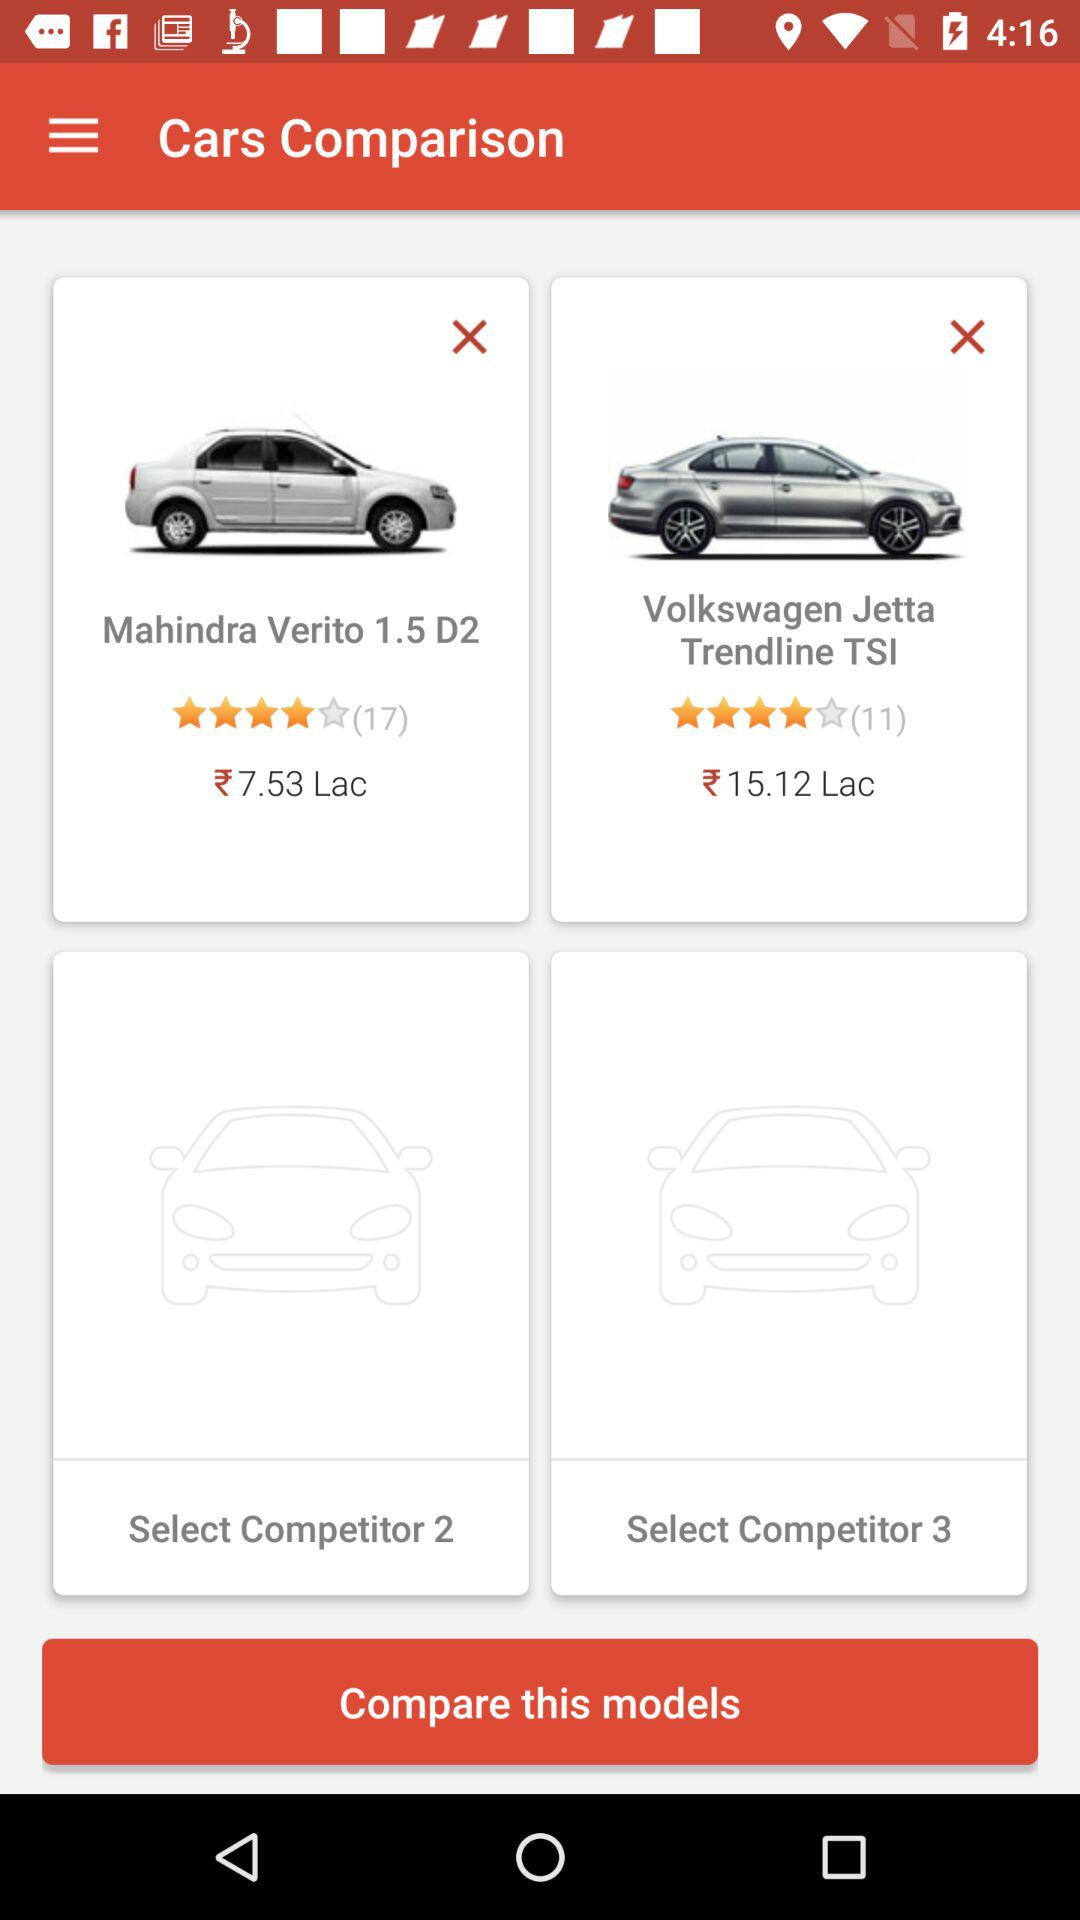How many competitors are there in this comparison?
Answer the question using a single word or phrase. 2 